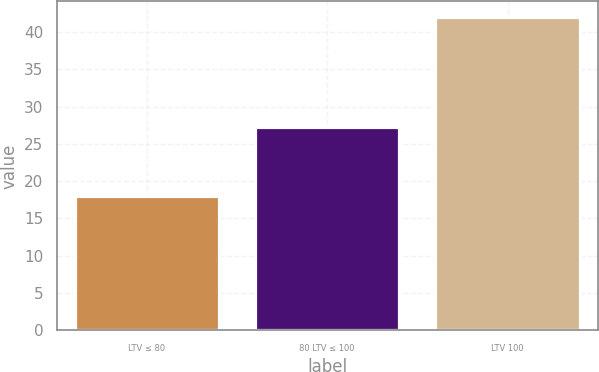Convert chart. <chart><loc_0><loc_0><loc_500><loc_500><bar_chart><fcel>LTV ≤ 80<fcel>80 LTV ≤ 100<fcel>LTV 100<nl><fcel>18<fcel>27.3<fcel>42<nl></chart> 